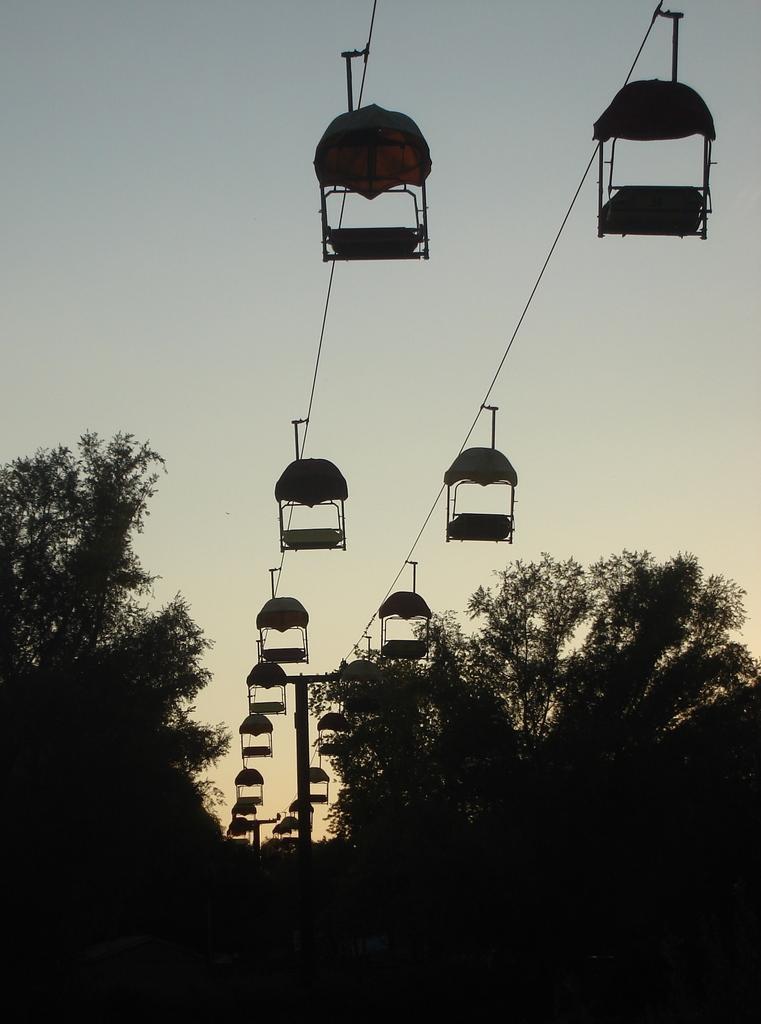Describe this image in one or two sentences. In this image at the bottom there are some trees, and in the center there are some cable cars, and wires and at the top of the image there is sky. 